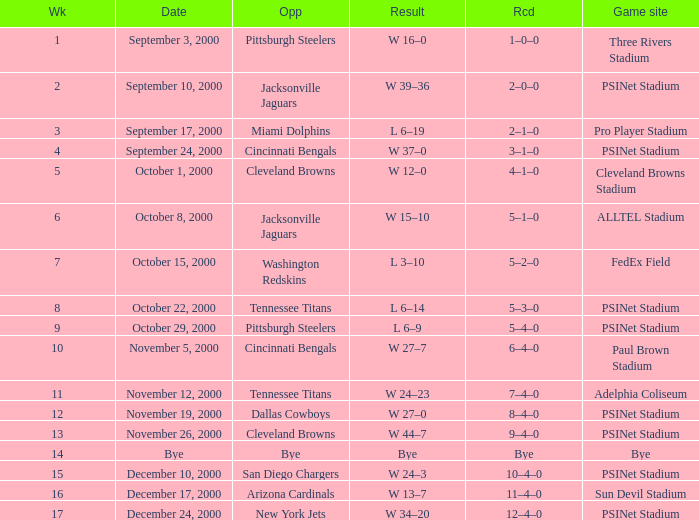What's the record after week 12 with a game site of bye? Bye. 